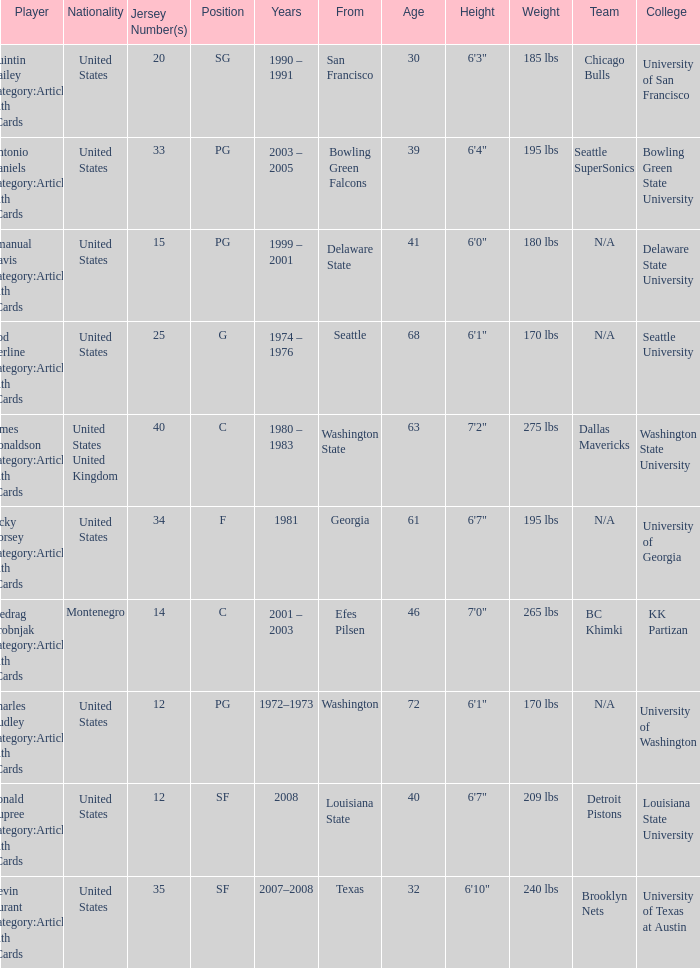I'm looking to parse the entire table for insights. Could you assist me with that? {'header': ['Player', 'Nationality', 'Jersey Number(s)', 'Position', 'Years', 'From', 'Age', 'Height', 'Weight', 'Team', 'College '], 'rows': [['Quintin Dailey Category:Articles with hCards', 'United States', '20', 'SG', '1990 – 1991', 'San Francisco', '30', '6\'3"', '185 lbs', 'Chicago Bulls', 'University of San Francisco'], ['Antonio Daniels Category:Articles with hCards', 'United States', '33', 'PG', '2003 – 2005', 'Bowling Green Falcons', '39', '6\'4"', '195 lbs', 'Seattle SuperSonics', 'Bowling Green State University'], ['Emanual Davis Category:Articles with hCards', 'United States', '15', 'PG', '1999 – 2001', 'Delaware State', '41', '6\'0"', '180 lbs', 'N/A', 'Delaware State University'], ['Rod Derline Category:Articles with hCards', 'United States', '25', 'G', '1974 – 1976', 'Seattle', '68', '6\'1"', '170 lbs', 'N/A', 'Seattle University'], ['James Donaldson Category:Articles with hCards', 'United States United Kingdom', '40', 'C', '1980 – 1983', 'Washington State', '63', '7\'2"', '275 lbs', 'Dallas Mavericks', 'Washington State University'], ['Jacky Dorsey Category:Articles with hCards', 'United States', '34', 'F', '1981', 'Georgia', '61', '6\'7"', '195 lbs', 'N/A', 'University of Georgia'], ['Predrag Drobnjak Category:Articles with hCards', 'Montenegro', '14', 'C', '2001 – 2003', 'Efes Pilsen', '46', '7\'0"', '265 lbs', 'BC Khimki', 'KK Partizan'], ['Charles Dudley Category:Articles with hCards', 'United States', '12', 'PG', '1972–1973', 'Washington', '72', '6\'1"', '170 lbs', 'N/A', 'University of Washington'], ['Ronald Dupree Category:Articles with hCards', 'United States', '12', 'SF', '2008', 'Louisiana State', '40', '6\'7"', '209 lbs', 'Detroit Pistons', 'Louisiana State University'], ['Kevin Durant Category:Articles with hCards', 'United States', '35', 'SF', '2007–2008', 'Texas', '32', '6\'10"', '240 lbs', 'Brooklyn Nets', 'University of Texas at Austin']]} What was the nationality of the players with a position of g? United States. 